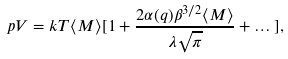<formula> <loc_0><loc_0><loc_500><loc_500>p V = k T \langle M \rangle [ 1 + \frac { 2 \alpha ( q ) \beta ^ { 3 / 2 } \langle M \rangle } { \lambda \sqrt { \pi } } + \dots ] ,</formula> 